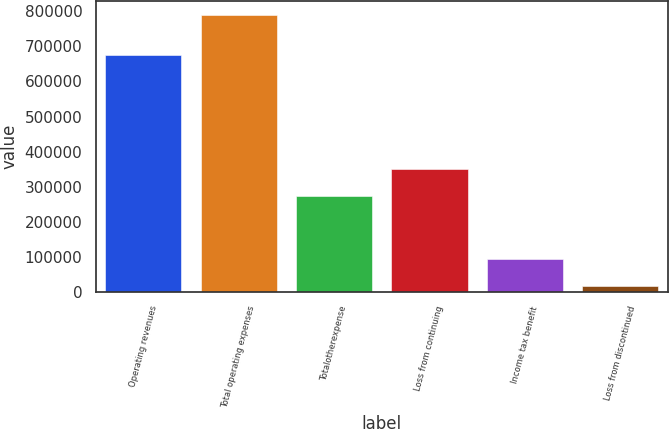<chart> <loc_0><loc_0><loc_500><loc_500><bar_chart><fcel>Operating revenues<fcel>Total operating expenses<fcel>Totalotherexpense<fcel>Loss from continuing<fcel>Income tax benefit<fcel>Loss from discontinued<nl><fcel>675082<fcel>789844<fcel>273558<fcel>350828<fcel>94418.5<fcel>17149<nl></chart> 